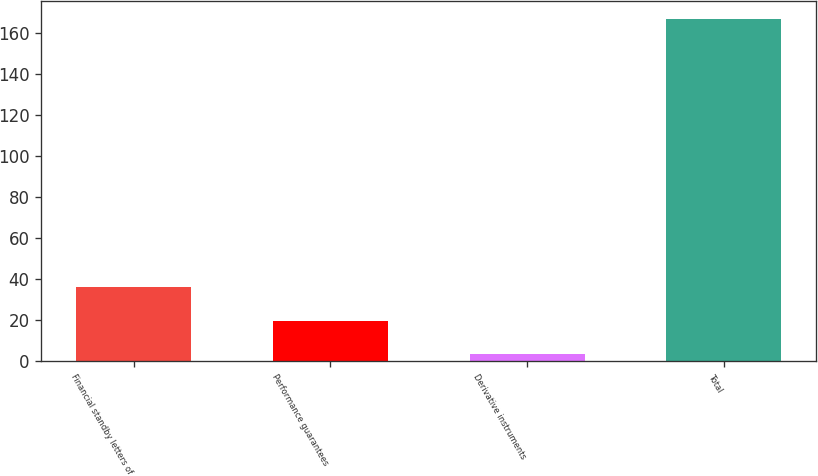<chart> <loc_0><loc_0><loc_500><loc_500><bar_chart><fcel>Financial standby letters of<fcel>Performance guarantees<fcel>Derivative instruments<fcel>Total<nl><fcel>35.9<fcel>19.5<fcel>3.1<fcel>167.1<nl></chart> 